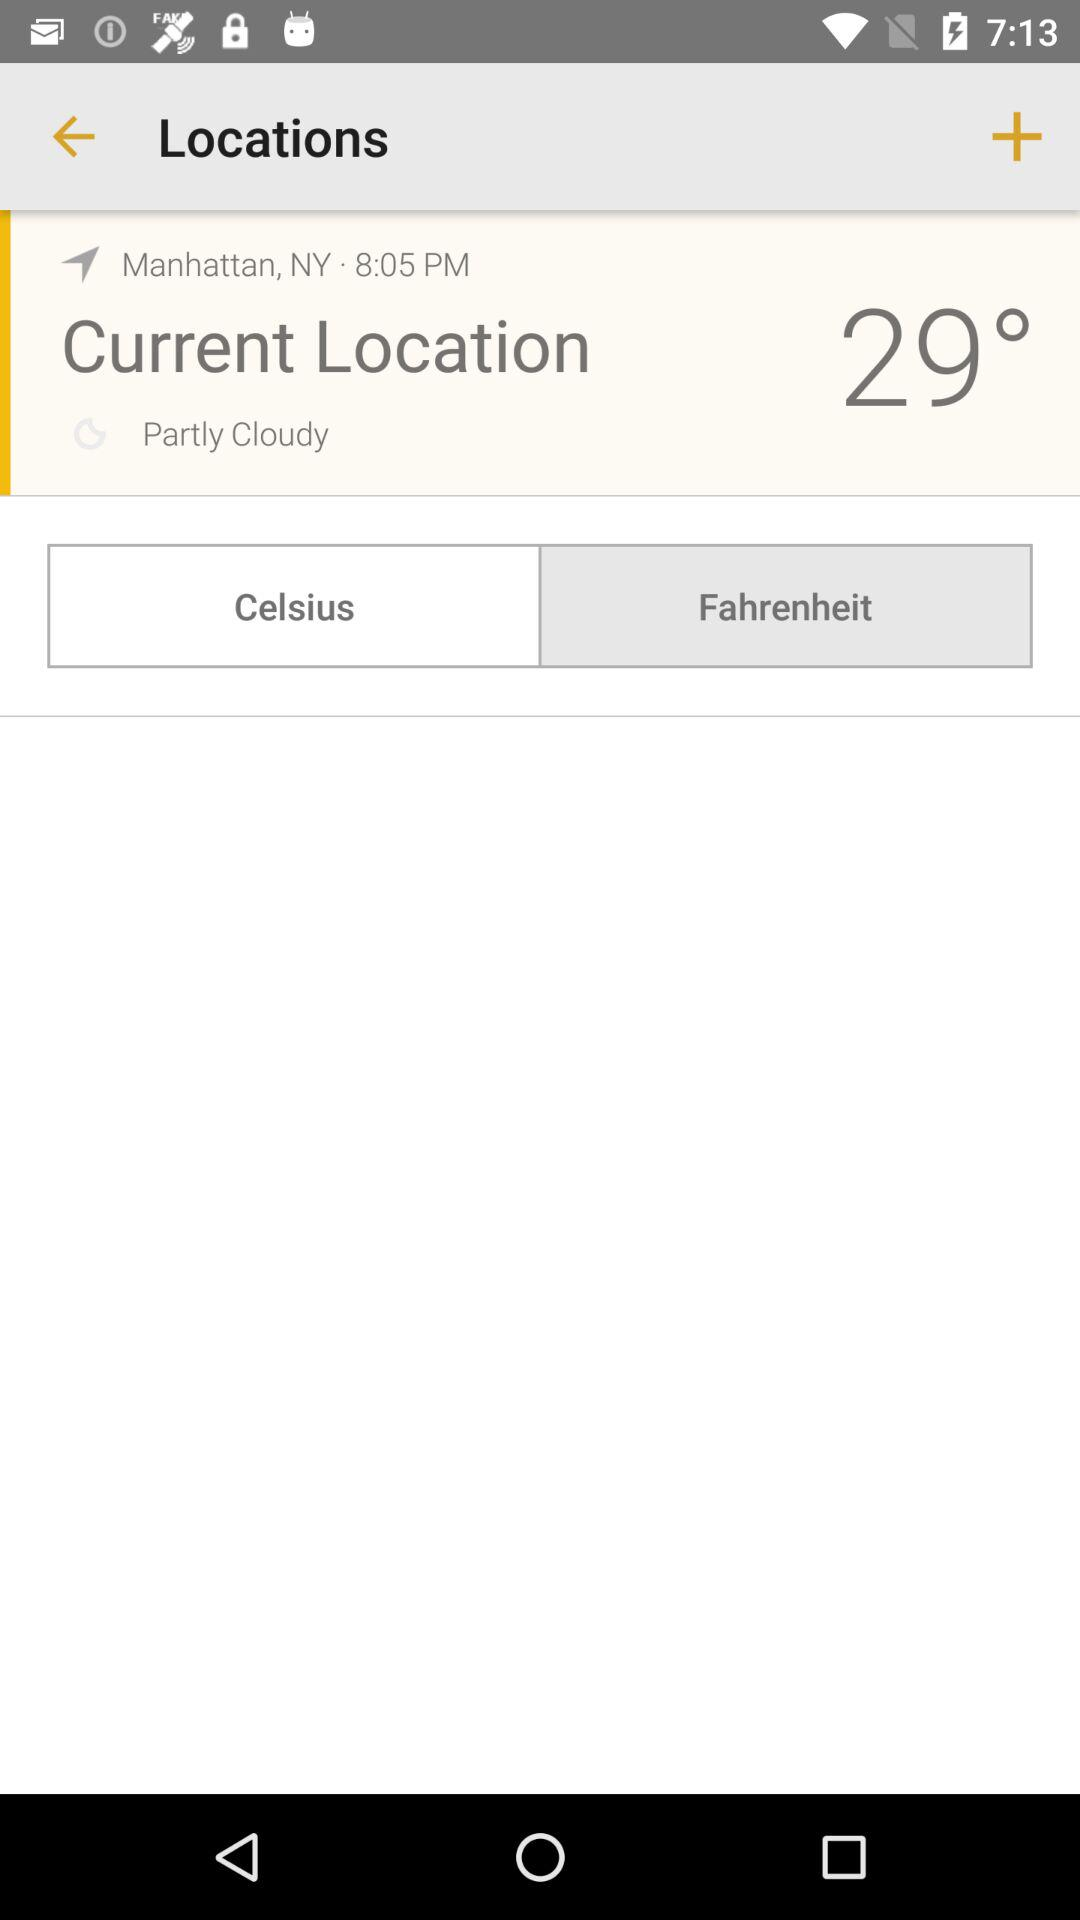What is the unit selected for temperature? The selected unit is Celsius. 